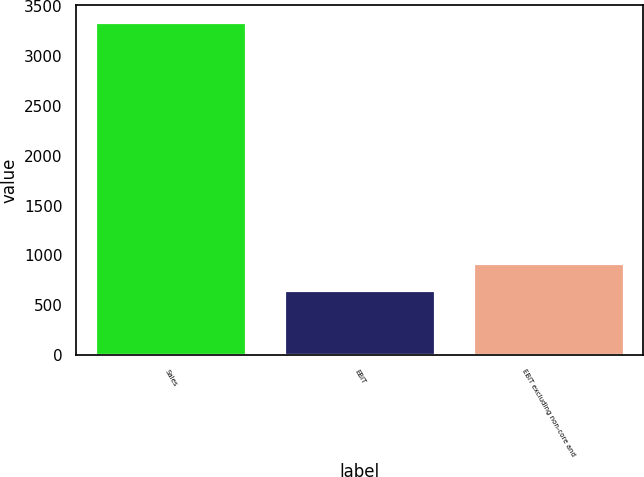Convert chart to OTSL. <chart><loc_0><loc_0><loc_500><loc_500><bar_chart><fcel>Sales<fcel>EBIT<fcel>EBIT excluding non-core and<nl><fcel>3343<fcel>653<fcel>922<nl></chart> 